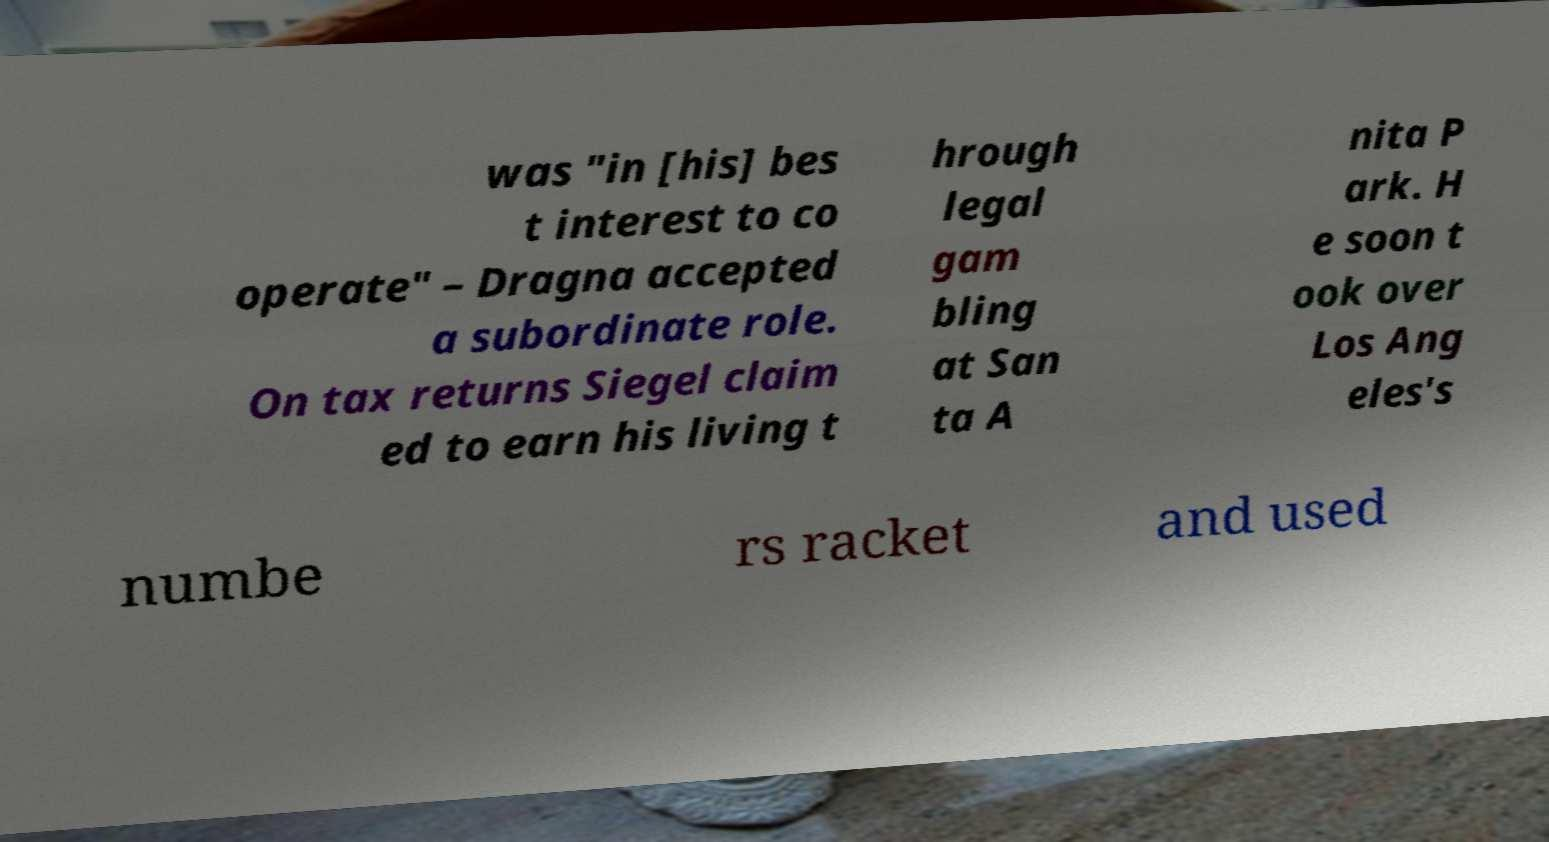There's text embedded in this image that I need extracted. Can you transcribe it verbatim? was "in [his] bes t interest to co operate" – Dragna accepted a subordinate role. On tax returns Siegel claim ed to earn his living t hrough legal gam bling at San ta A nita P ark. H e soon t ook over Los Ang eles's numbe rs racket and used 